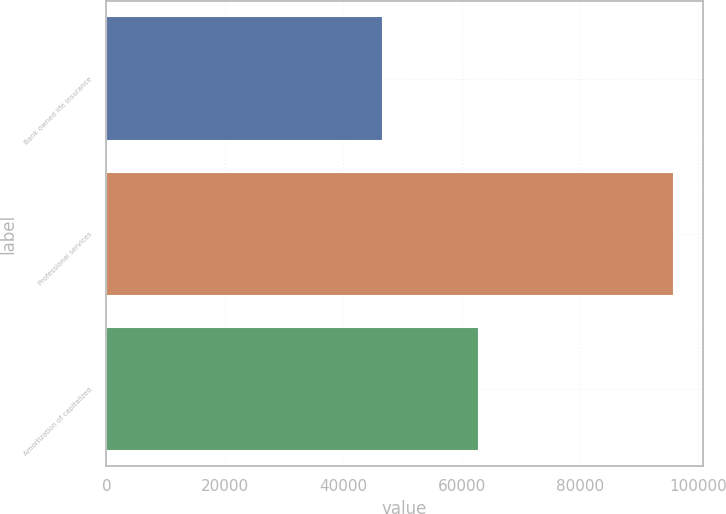Convert chart. <chart><loc_0><loc_0><loc_500><loc_500><bar_chart><fcel>Bank owned life insurance<fcel>Professional services<fcel>Amortization of capitalized<nl><fcel>46723<fcel>95912<fcel>62931<nl></chart> 